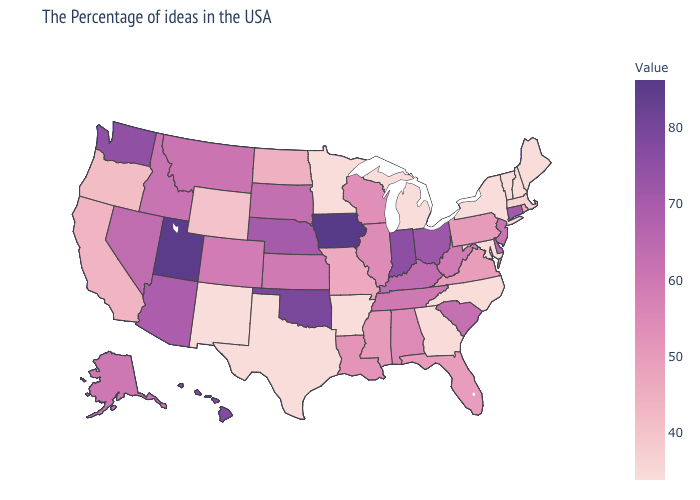Does Indiana have a lower value than Arkansas?
Answer briefly. No. Does the map have missing data?
Short answer required. No. Among the states that border Iowa , which have the lowest value?
Give a very brief answer. Minnesota. Is the legend a continuous bar?
Answer briefly. Yes. Does the map have missing data?
Give a very brief answer. No. 